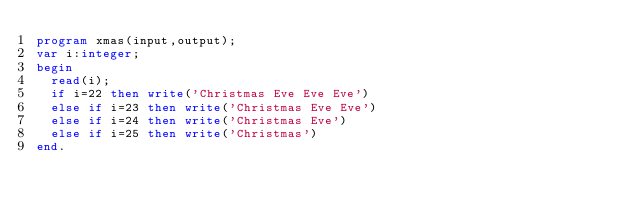<code> <loc_0><loc_0><loc_500><loc_500><_Pascal_>program xmas(input,output);
var i:integer;
begin
  read(i);
  if i=22 then write('Christmas Eve Eve Eve')
  else if i=23 then write('Christmas Eve Eve')
  else if i=24 then write('Christmas Eve')
  else if i=25 then write('Christmas')
end.</code> 